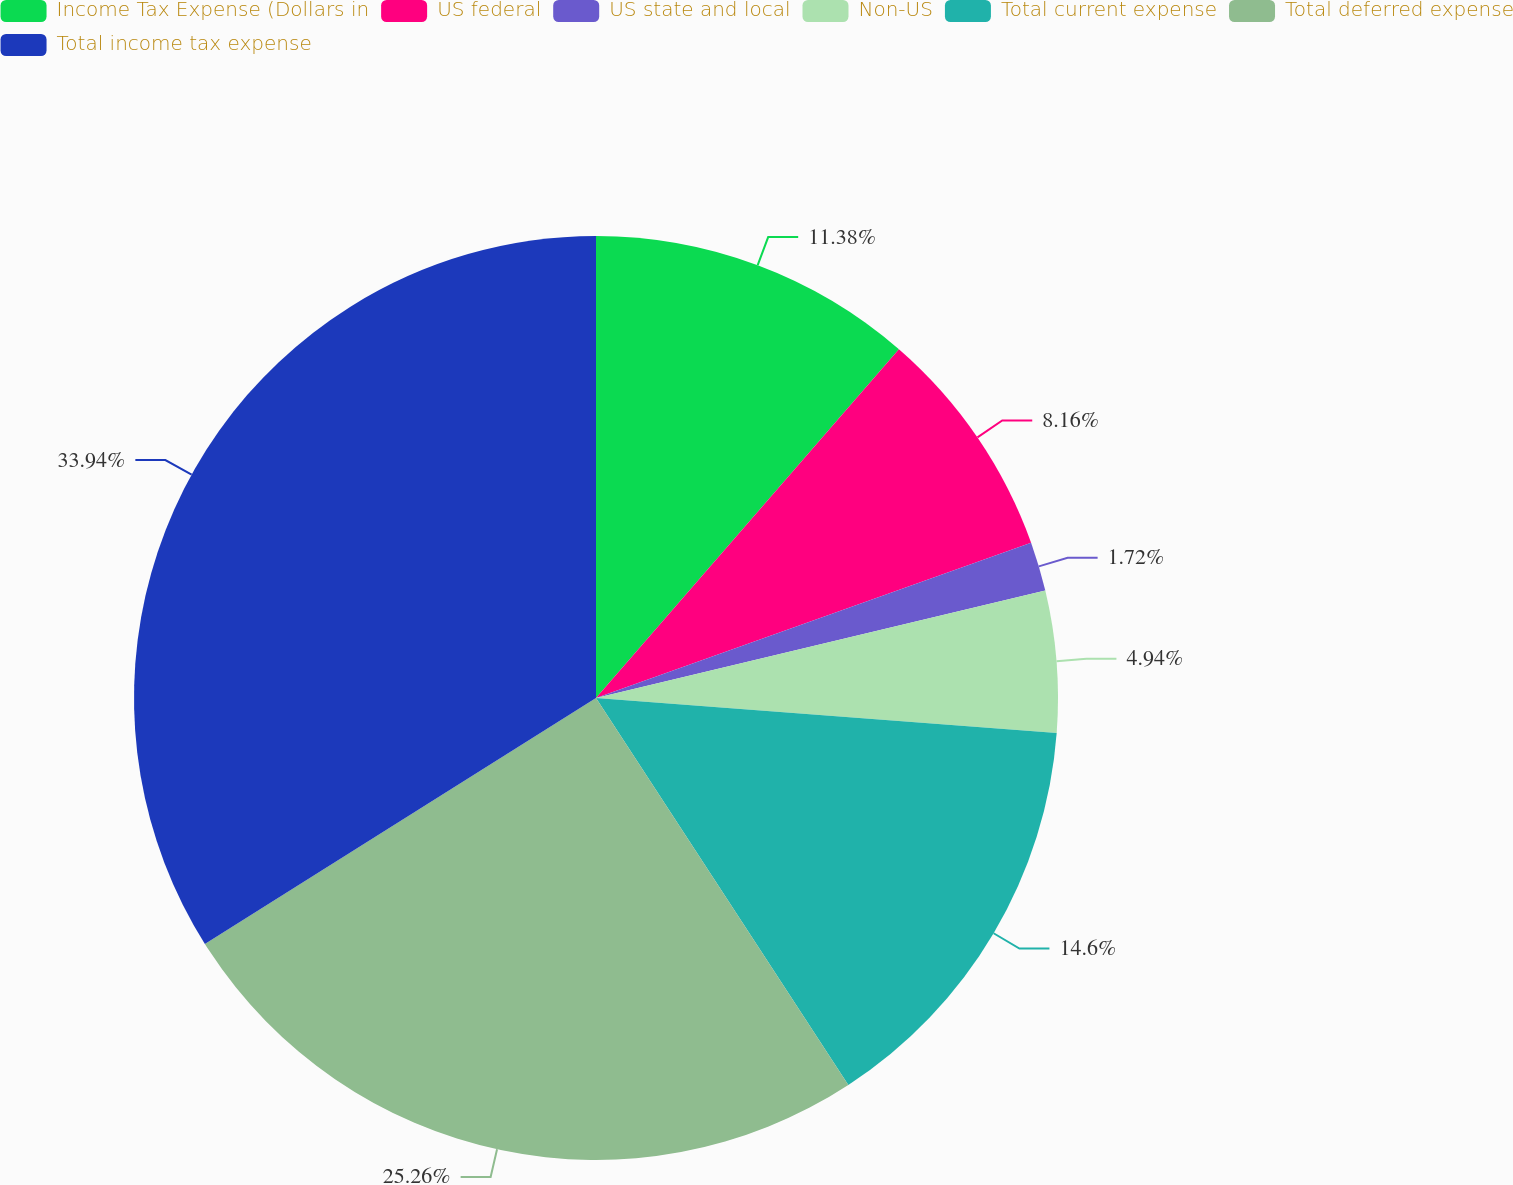Convert chart to OTSL. <chart><loc_0><loc_0><loc_500><loc_500><pie_chart><fcel>Income Tax Expense (Dollars in<fcel>US federal<fcel>US state and local<fcel>Non-US<fcel>Total current expense<fcel>Total deferred expense<fcel>Total income tax expense<nl><fcel>11.38%<fcel>8.16%<fcel>1.72%<fcel>4.94%<fcel>14.6%<fcel>25.26%<fcel>33.93%<nl></chart> 